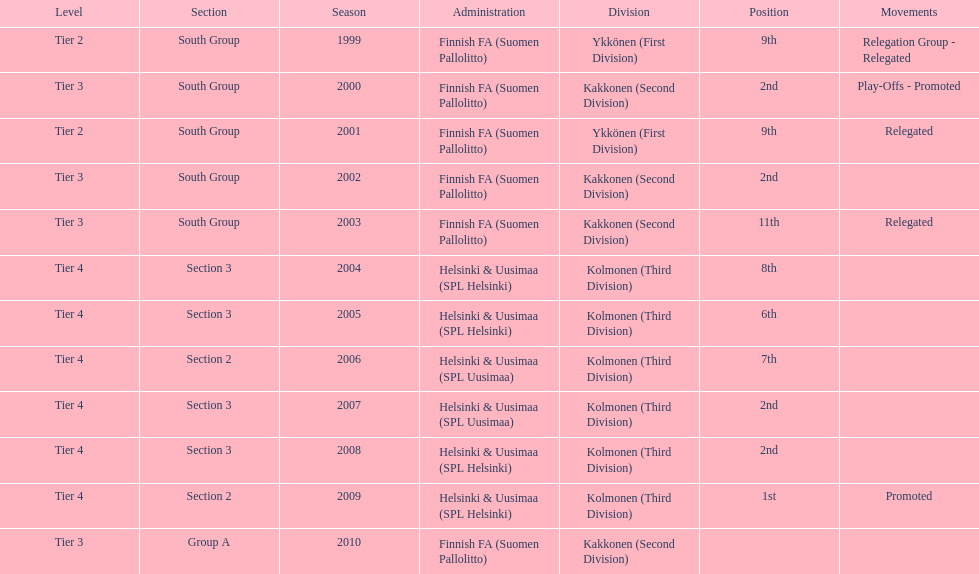Of the third division, how many were in section3? 4. 